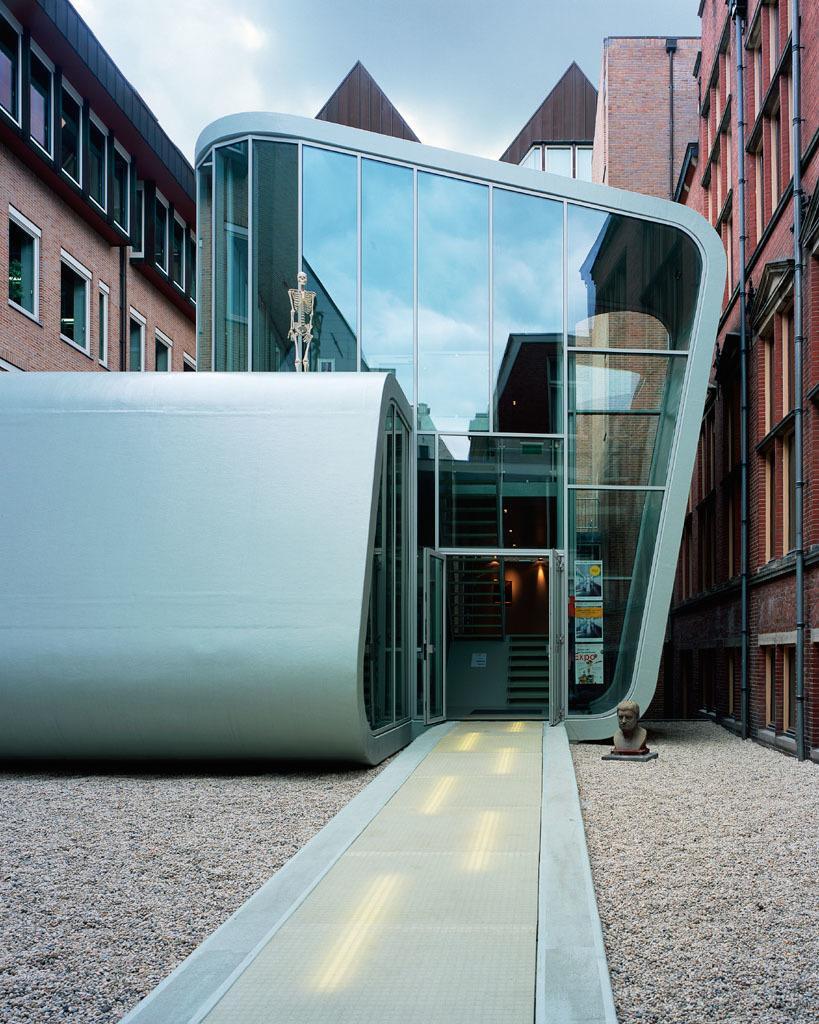In one or two sentences, can you explain what this image depicts? In this image there is the sky truncated towards the top of the image, there are buildings truncated towards the right of the image, there are buildings truncated towards the left of the image, there is a sculpture on the ground, there is a skeleton on the building, there are posters on the glass, there are lights on the ground. 